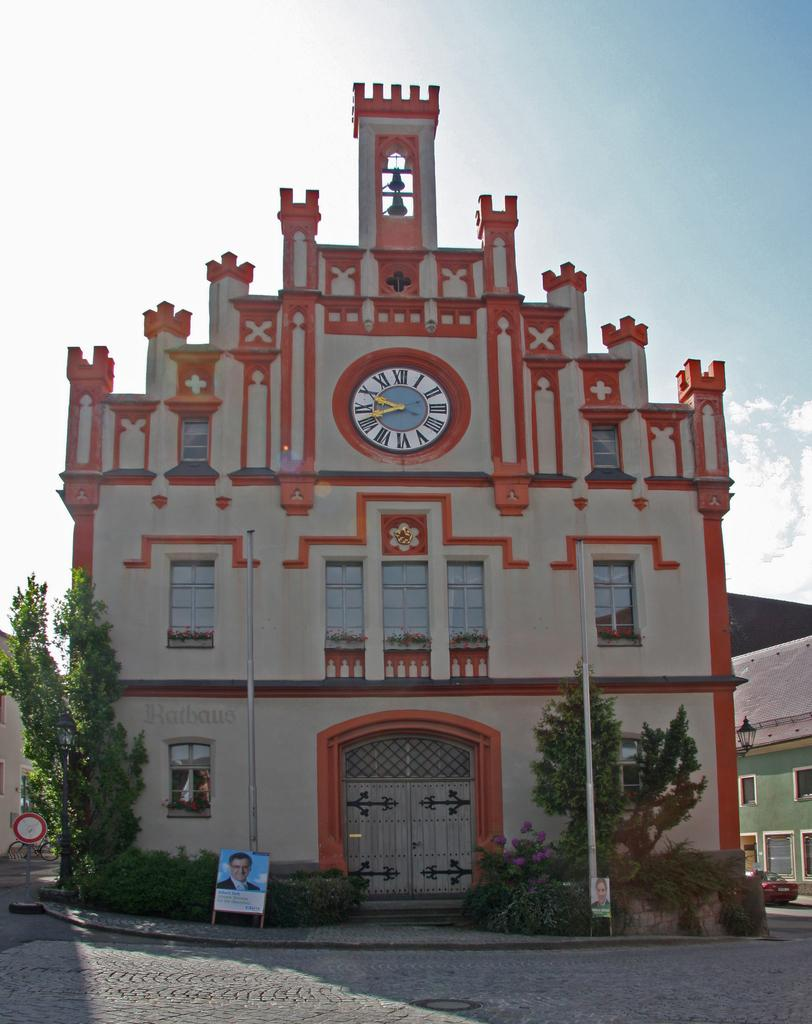What type of structure is in the image? There is a building in the image. What feature is present in the middle of the building? The building has a clock in the middle. What can be seen on either side of the building? There are trees on either side of the building. What is in front of the building? There is a road in front of the building. What is visible above the building? The sky is visible above the building. What can be observed in the sky? Clouds are present in the sky. What language is spoken by the sticks in the image? There are no sticks present in the image, and therefore no language can be attributed to them. 